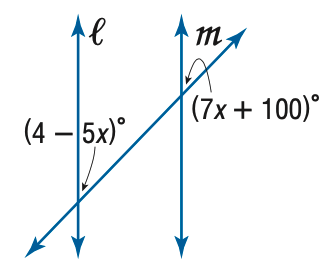Question: Find x so that m \parallel n.
Choices:
A. - 8
B. 8
C. 8.67
D. 48
Answer with the letter. Answer: A 